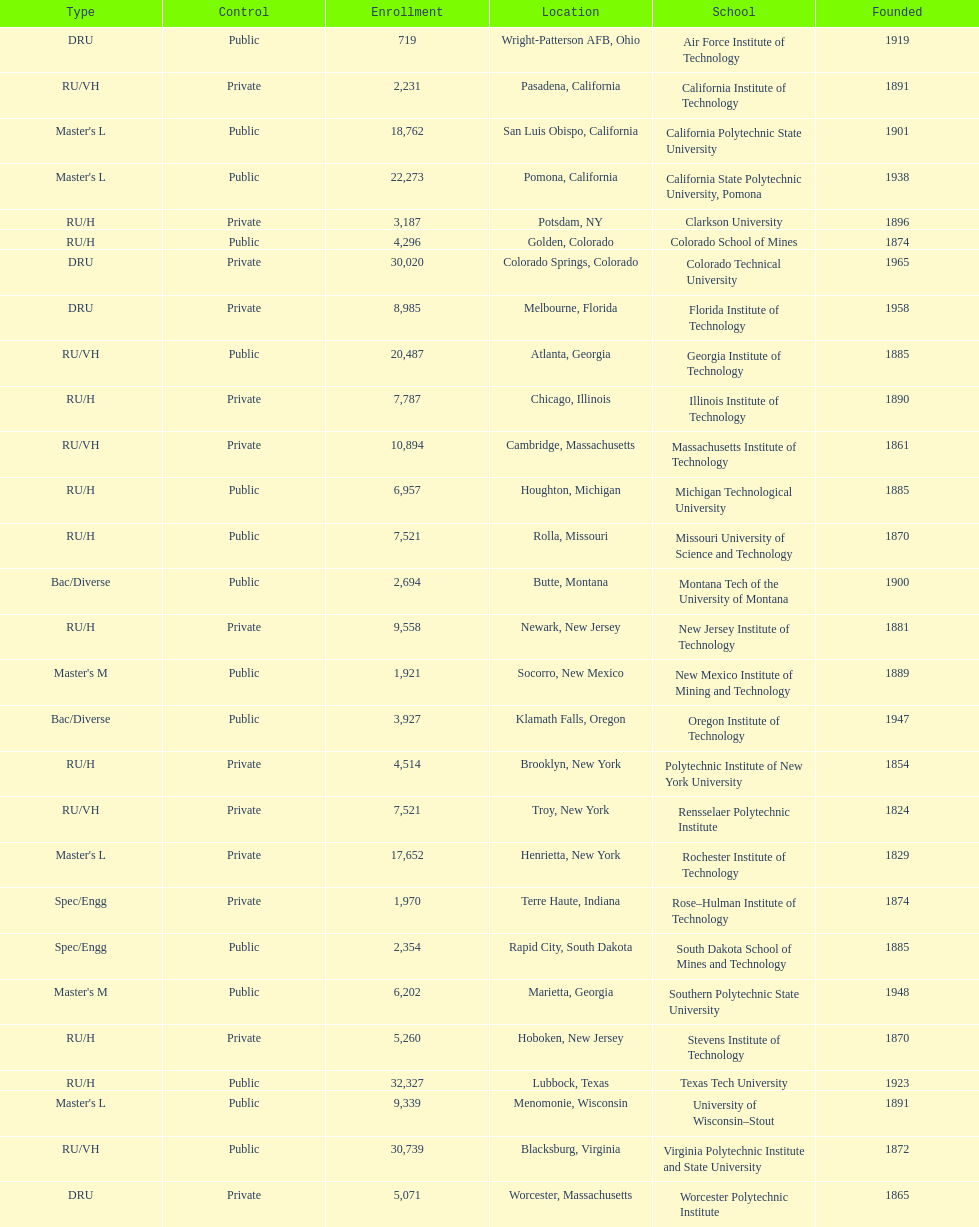How many of the universities were located in california? 3. 